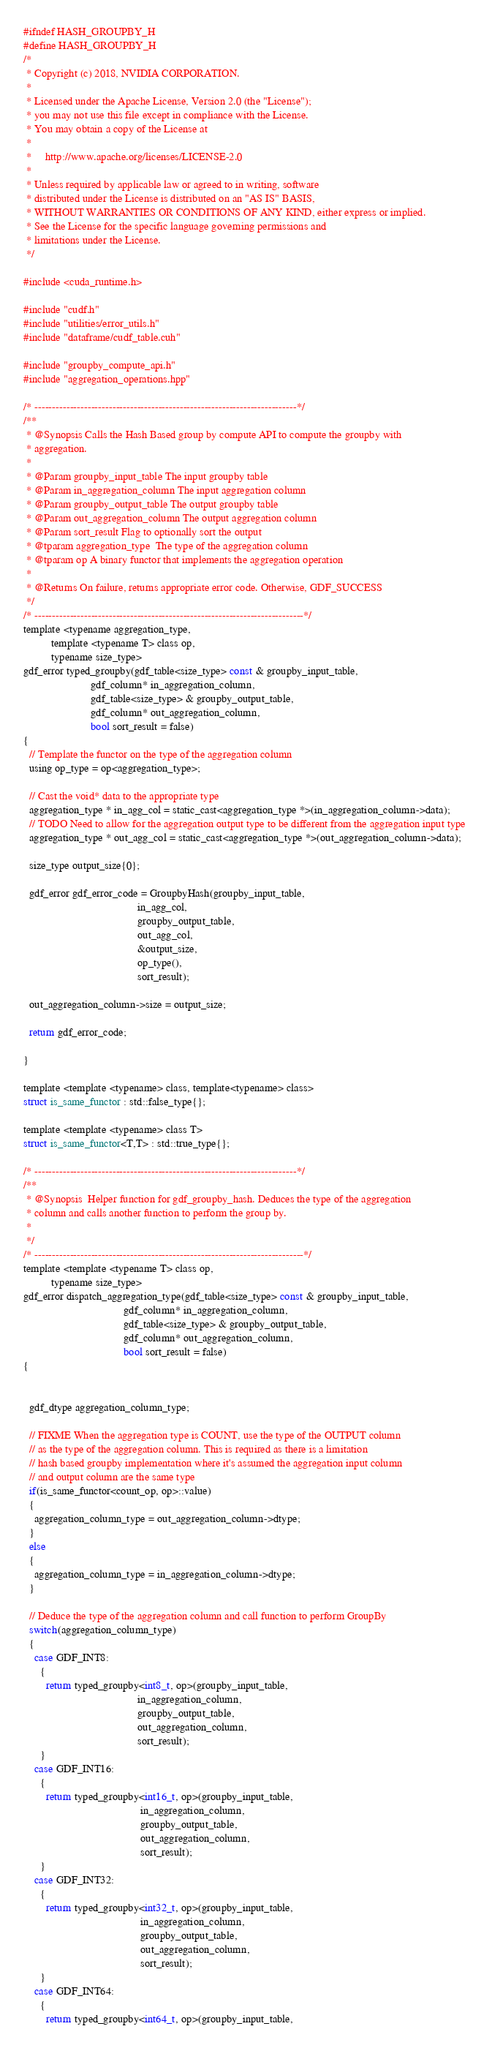<code> <loc_0><loc_0><loc_500><loc_500><_Cuda_>#ifndef HASH_GROUPBY_H
#define HASH_GROUPBY_H
/*
 * Copyright (c) 2018, NVIDIA CORPORATION.
 *
 * Licensed under the Apache License, Version 2.0 (the "License");
 * you may not use this file except in compliance with the License.
 * You may obtain a copy of the License at
 *
 *     http://www.apache.org/licenses/LICENSE-2.0
 *
 * Unless required by applicable law or agreed to in writing, software
 * distributed under the License is distributed on an "AS IS" BASIS,
 * WITHOUT WARRANTIES OR CONDITIONS OF ANY KIND, either express or implied.
 * See the License for the specific language governing permissions and
 * limitations under the License.
 */

#include <cuda_runtime.h>

#include "cudf.h"
#include "utilities/error_utils.h"
#include "dataframe/cudf_table.cuh"

#include "groupby_compute_api.h"
#include "aggregation_operations.hpp"

/* --------------------------------------------------------------------------*/
/** 
 * @Synopsis Calls the Hash Based group by compute API to compute the groupby with 
 * aggregation.
 * 
 * @Param groupby_input_table The input groupby table
 * @Param in_aggregation_column The input aggregation column
 * @Param groupby_output_table The output groupby table
 * @Param out_aggregation_column The output aggregation column
 * @Param sort_result Flag to optionally sort the output
 * @tparam aggregation_type  The type of the aggregation column
 * @tparam op A binary functor that implements the aggregation operation
 * 
 * @Returns On failure, returns appropriate error code. Otherwise, GDF_SUCCESS
 */
/* ----------------------------------------------------------------------------*/
template <typename aggregation_type, 
          template <typename T> class op,
          typename size_type>
gdf_error typed_groupby(gdf_table<size_type> const & groupby_input_table,
                        gdf_column* in_aggregation_column,       
                        gdf_table<size_type> & groupby_output_table,
                        gdf_column* out_aggregation_column,
                        bool sort_result = false)
{
  // Template the functor on the type of the aggregation column
  using op_type = op<aggregation_type>;

  // Cast the void* data to the appropriate type
  aggregation_type * in_agg_col = static_cast<aggregation_type *>(in_aggregation_column->data);
  // TODO Need to allow for the aggregation output type to be different from the aggregation input type
  aggregation_type * out_agg_col = static_cast<aggregation_type *>(out_aggregation_column->data);

  size_type output_size{0};

  gdf_error gdf_error_code = GroupbyHash(groupby_input_table, 
                                         in_agg_col, 
                                         groupby_output_table, 
                                         out_agg_col, 
                                         &output_size, 
                                         op_type(), 
                                         sort_result);

  out_aggregation_column->size = output_size;

  return gdf_error_code;

}

template <template <typename> class, template<typename> class>
struct is_same_functor : std::false_type{};

template <template <typename> class T>
struct is_same_functor<T,T> : std::true_type{};

/* --------------------------------------------------------------------------*/
/** 
 * @Synopsis  Helper function for gdf_groupby_hash. Deduces the type of the aggregation
 * column and calls another function to perform the group by.
 * 
 */
/* ----------------------------------------------------------------------------*/
template <template <typename T> class op,
          typename size_type>
gdf_error dispatch_aggregation_type(gdf_table<size_type> const & groupby_input_table,        
                                    gdf_column* in_aggregation_column,       
                                    gdf_table<size_type> & groupby_output_table,
                                    gdf_column* out_aggregation_column,
                                    bool sort_result = false)
{


  gdf_dtype aggregation_column_type;

  // FIXME When the aggregation type is COUNT, use the type of the OUTPUT column
  // as the type of the aggregation column. This is required as there is a limitation 
  // hash based groupby implementation where it's assumed the aggregation input column
  // and output column are the same type
  if(is_same_functor<count_op, op>::value)
  {
    aggregation_column_type = out_aggregation_column->dtype;
  }
  else
  {
    aggregation_column_type = in_aggregation_column->dtype;
  }

  // Deduce the type of the aggregation column and call function to perform GroupBy
  switch(aggregation_column_type)
  {
    case GDF_INT8:   
      { 
        return typed_groupby<int8_t, op>(groupby_input_table, 
                                         in_aggregation_column, 
                                         groupby_output_table, 
                                         out_aggregation_column, 
                                         sort_result);
      }
    case GDF_INT16:  
      { 
        return typed_groupby<int16_t, op>(groupby_input_table, 
                                          in_aggregation_column, 
                                          groupby_output_table, 
                                          out_aggregation_column, 
                                          sort_result);
      }
    case GDF_INT32:  
      { 
        return typed_groupby<int32_t, op>(groupby_input_table, 
                                          in_aggregation_column, 
                                          groupby_output_table, 
                                          out_aggregation_column, 
                                          sort_result);
      }
    case GDF_INT64:  
      { 
        return typed_groupby<int64_t, op>(groupby_input_table, </code> 